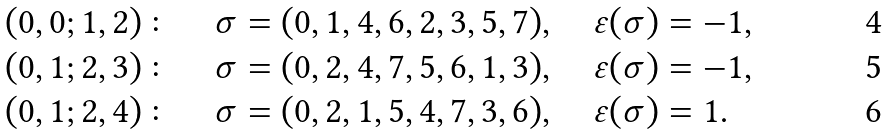<formula> <loc_0><loc_0><loc_500><loc_500>( 0 , 0 ; 1 , 2 ) \colon & \quad \sigma = ( 0 , 1 , 4 , 6 , 2 , 3 , 5 , 7 ) , \quad \varepsilon ( \sigma ) = - 1 , \\ ( 0 , 1 ; 2 , 3 ) \colon & \quad \sigma = ( 0 , 2 , 4 , 7 , 5 , 6 , 1 , 3 ) , \quad \varepsilon ( \sigma ) = - 1 , \\ ( 0 , 1 ; 2 , 4 ) \colon & \quad \sigma = ( 0 , 2 , 1 , 5 , 4 , 7 , 3 , 6 ) , \quad \varepsilon ( \sigma ) = 1 .</formula> 